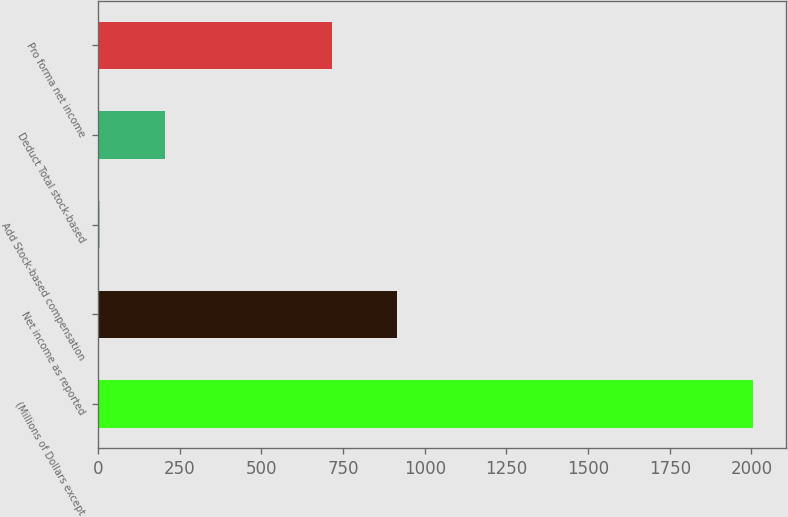Convert chart. <chart><loc_0><loc_0><loc_500><loc_500><bar_chart><fcel>(Millions of Dollars except<fcel>Net income as reported<fcel>Add Stock-based compensation<fcel>Deduct Total stock-based<fcel>Pro forma net income<nl><fcel>2005<fcel>914.9<fcel>6<fcel>205.9<fcel>715<nl></chart> 